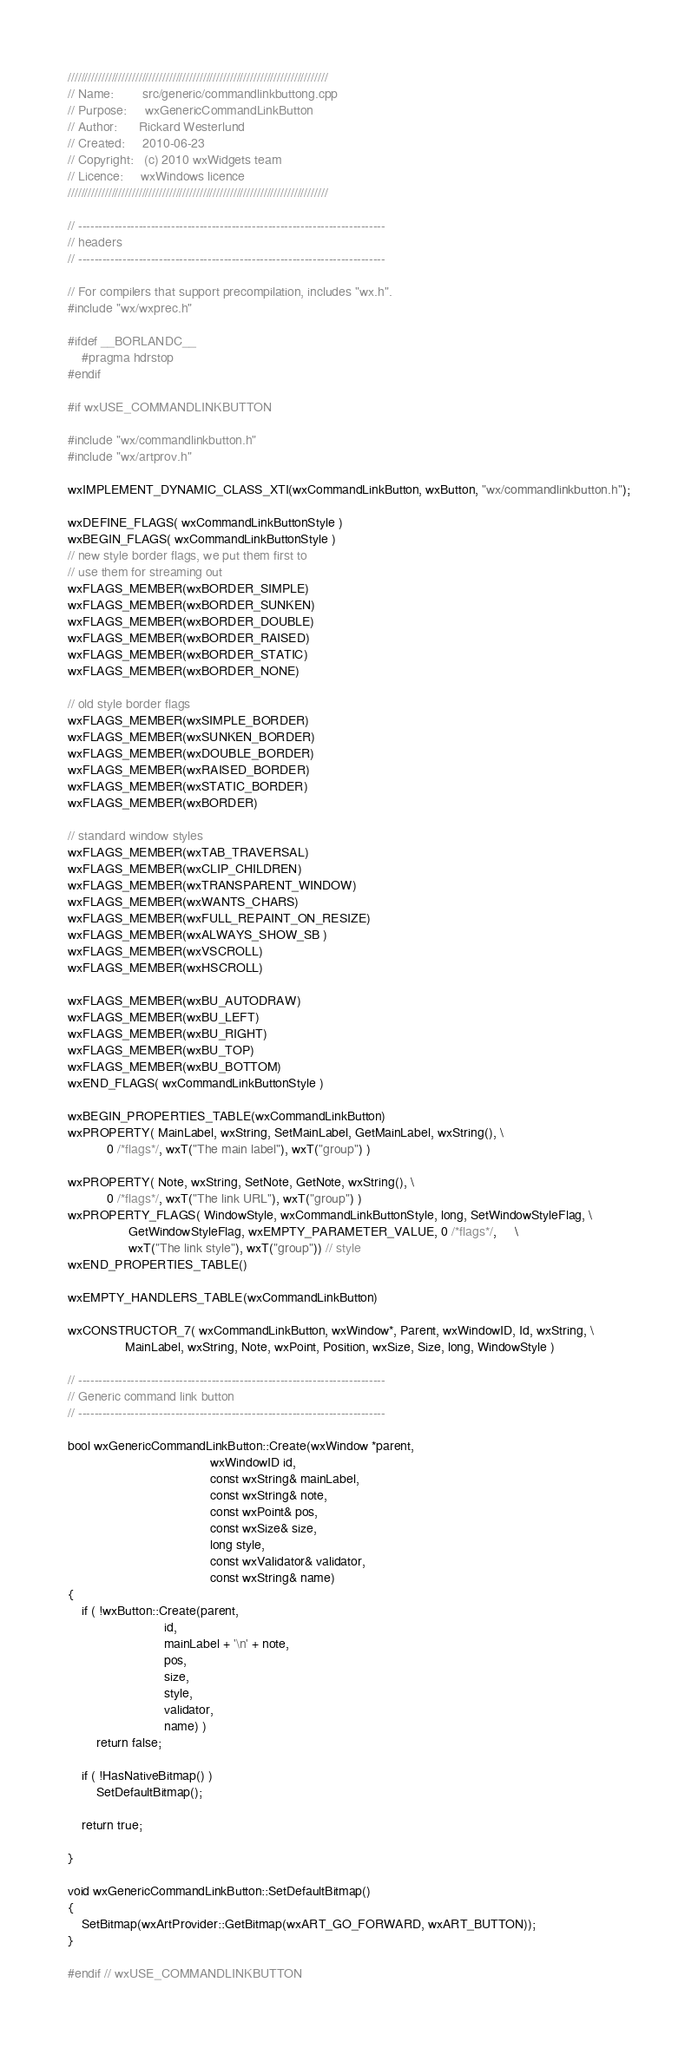Convert code to text. <code><loc_0><loc_0><loc_500><loc_500><_C++_>/////////////////////////////////////////////////////////////////////////////
// Name:        src/generic/commandlinkbuttong.cpp
// Purpose:     wxGenericCommandLinkButton
// Author:      Rickard Westerlund
// Created:     2010-06-23
// Copyright:   (c) 2010 wxWidgets team
// Licence:     wxWindows licence
/////////////////////////////////////////////////////////////////////////////

// ----------------------------------------------------------------------------
// headers
// ----------------------------------------------------------------------------

// For compilers that support precompilation, includes "wx.h".
#include "wx/wxprec.h"

#ifdef __BORLANDC__
    #pragma hdrstop
#endif

#if wxUSE_COMMANDLINKBUTTON

#include "wx/commandlinkbutton.h"
#include "wx/artprov.h"

wxIMPLEMENT_DYNAMIC_CLASS_XTI(wxCommandLinkButton, wxButton, "wx/commandlinkbutton.h");

wxDEFINE_FLAGS( wxCommandLinkButtonStyle )
wxBEGIN_FLAGS( wxCommandLinkButtonStyle )
// new style border flags, we put them first to
// use them for streaming out
wxFLAGS_MEMBER(wxBORDER_SIMPLE)
wxFLAGS_MEMBER(wxBORDER_SUNKEN)
wxFLAGS_MEMBER(wxBORDER_DOUBLE)
wxFLAGS_MEMBER(wxBORDER_RAISED)
wxFLAGS_MEMBER(wxBORDER_STATIC)
wxFLAGS_MEMBER(wxBORDER_NONE)

// old style border flags
wxFLAGS_MEMBER(wxSIMPLE_BORDER)
wxFLAGS_MEMBER(wxSUNKEN_BORDER)
wxFLAGS_MEMBER(wxDOUBLE_BORDER)
wxFLAGS_MEMBER(wxRAISED_BORDER)
wxFLAGS_MEMBER(wxSTATIC_BORDER)
wxFLAGS_MEMBER(wxBORDER)

// standard window styles
wxFLAGS_MEMBER(wxTAB_TRAVERSAL)
wxFLAGS_MEMBER(wxCLIP_CHILDREN)
wxFLAGS_MEMBER(wxTRANSPARENT_WINDOW)
wxFLAGS_MEMBER(wxWANTS_CHARS)
wxFLAGS_MEMBER(wxFULL_REPAINT_ON_RESIZE)
wxFLAGS_MEMBER(wxALWAYS_SHOW_SB )
wxFLAGS_MEMBER(wxVSCROLL)
wxFLAGS_MEMBER(wxHSCROLL)

wxFLAGS_MEMBER(wxBU_AUTODRAW)
wxFLAGS_MEMBER(wxBU_LEFT)
wxFLAGS_MEMBER(wxBU_RIGHT)
wxFLAGS_MEMBER(wxBU_TOP)
wxFLAGS_MEMBER(wxBU_BOTTOM)
wxEND_FLAGS( wxCommandLinkButtonStyle )

wxBEGIN_PROPERTIES_TABLE(wxCommandLinkButton)
wxPROPERTY( MainLabel, wxString, SetMainLabel, GetMainLabel, wxString(), \
           0 /*flags*/, wxT("The main label"), wxT("group") )

wxPROPERTY( Note, wxString, SetNote, GetNote, wxString(), \
           0 /*flags*/, wxT("The link URL"), wxT("group") )
wxPROPERTY_FLAGS( WindowStyle, wxCommandLinkButtonStyle, long, SetWindowStyleFlag, \
                 GetWindowStyleFlag, wxEMPTY_PARAMETER_VALUE, 0 /*flags*/,     \
                 wxT("The link style"), wxT("group")) // style
wxEND_PROPERTIES_TABLE()

wxEMPTY_HANDLERS_TABLE(wxCommandLinkButton)

wxCONSTRUCTOR_7( wxCommandLinkButton, wxWindow*, Parent, wxWindowID, Id, wxString, \
                MainLabel, wxString, Note, wxPoint, Position, wxSize, Size, long, WindowStyle )

// ----------------------------------------------------------------------------
// Generic command link button
// ----------------------------------------------------------------------------

bool wxGenericCommandLinkButton::Create(wxWindow *parent,
                                        wxWindowID id,
                                        const wxString& mainLabel,
                                        const wxString& note,
                                        const wxPoint& pos,
                                        const wxSize& size,
                                        long style,
                                        const wxValidator& validator,
                                        const wxString& name)
{
    if ( !wxButton::Create(parent,
                           id,
                           mainLabel + '\n' + note,
                           pos,
                           size,
                           style,
                           validator,
                           name) )
        return false;

    if ( !HasNativeBitmap() )
        SetDefaultBitmap();

    return true;

}

void wxGenericCommandLinkButton::SetDefaultBitmap()
{
    SetBitmap(wxArtProvider::GetBitmap(wxART_GO_FORWARD, wxART_BUTTON));
}

#endif // wxUSE_COMMANDLINKBUTTON
</code> 